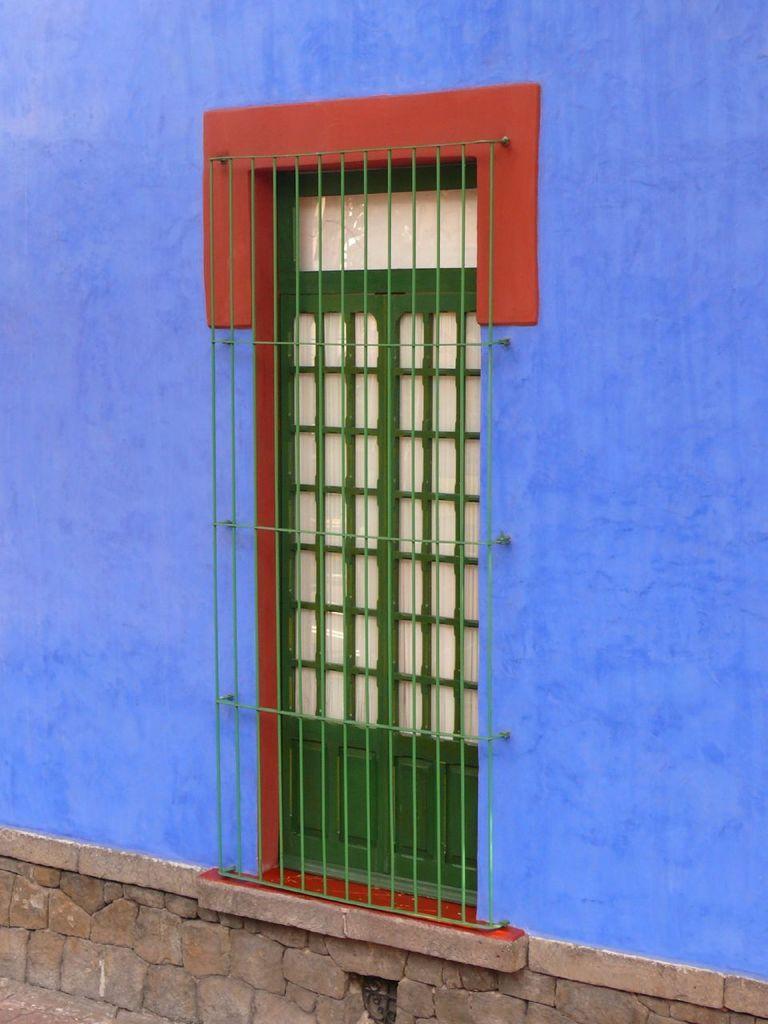Describe this image in one or two sentences. In the center of the image there is a door. In the background of the image there is a wall. 